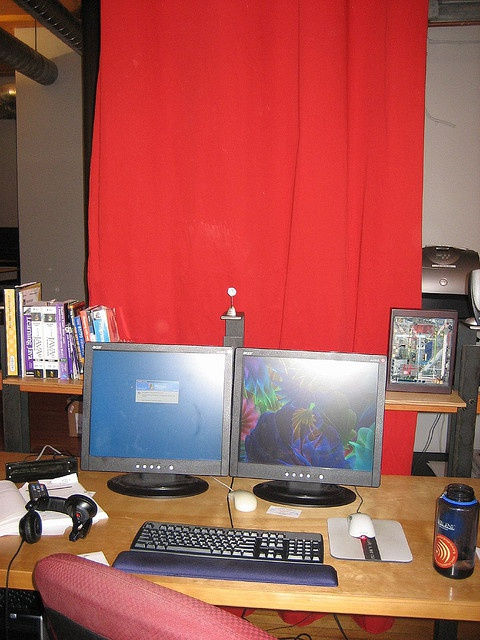Describe the objects in this image and their specific colors. I can see tv in maroon, darkgray, lightgray, and gray tones, tv in maroon, gray, and lightgray tones, chair in maroon, brown, and salmon tones, keyboard in maroon, black, gray, darkgray, and lightgray tones, and bottle in maroon, black, navy, and gray tones in this image. 